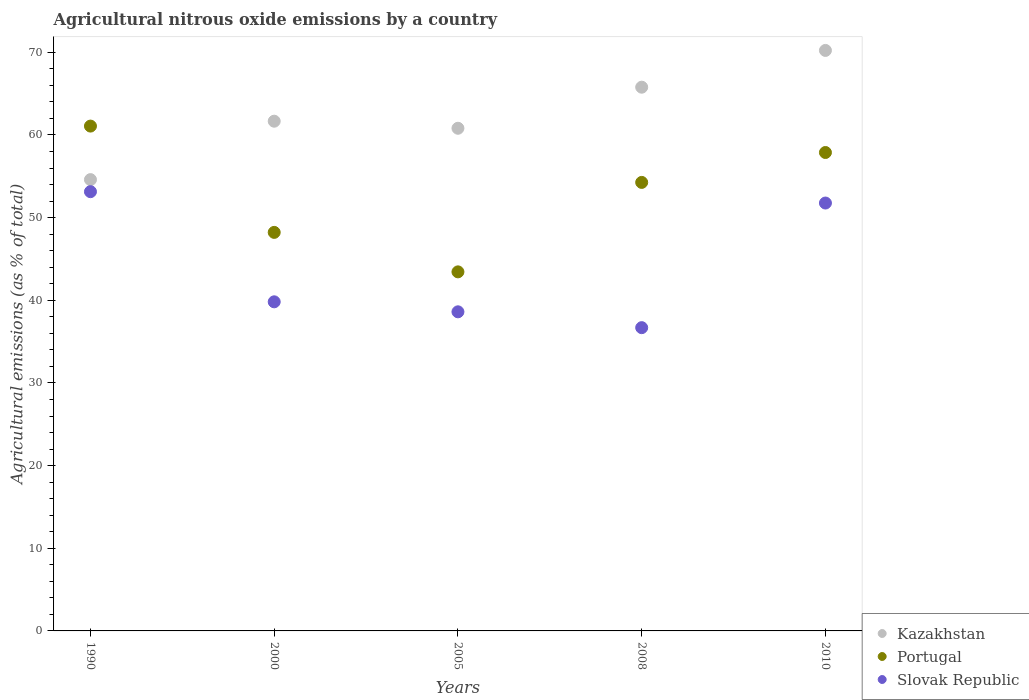How many different coloured dotlines are there?
Ensure brevity in your answer.  3. Is the number of dotlines equal to the number of legend labels?
Your answer should be very brief. Yes. What is the amount of agricultural nitrous oxide emitted in Kazakhstan in 2010?
Give a very brief answer. 70.22. Across all years, what is the maximum amount of agricultural nitrous oxide emitted in Portugal?
Ensure brevity in your answer.  61.07. Across all years, what is the minimum amount of agricultural nitrous oxide emitted in Portugal?
Your answer should be compact. 43.44. In which year was the amount of agricultural nitrous oxide emitted in Portugal minimum?
Offer a very short reply. 2005. What is the total amount of agricultural nitrous oxide emitted in Portugal in the graph?
Ensure brevity in your answer.  264.86. What is the difference between the amount of agricultural nitrous oxide emitted in Kazakhstan in 2005 and that in 2008?
Make the answer very short. -4.97. What is the difference between the amount of agricultural nitrous oxide emitted in Slovak Republic in 2000 and the amount of agricultural nitrous oxide emitted in Portugal in 2010?
Provide a succinct answer. -18.06. What is the average amount of agricultural nitrous oxide emitted in Kazakhstan per year?
Ensure brevity in your answer.  62.61. In the year 2005, what is the difference between the amount of agricultural nitrous oxide emitted in Slovak Republic and amount of agricultural nitrous oxide emitted in Portugal?
Offer a terse response. -4.83. In how many years, is the amount of agricultural nitrous oxide emitted in Portugal greater than 58 %?
Make the answer very short. 1. What is the ratio of the amount of agricultural nitrous oxide emitted in Portugal in 2008 to that in 2010?
Make the answer very short. 0.94. Is the difference between the amount of agricultural nitrous oxide emitted in Slovak Republic in 1990 and 2005 greater than the difference between the amount of agricultural nitrous oxide emitted in Portugal in 1990 and 2005?
Make the answer very short. No. What is the difference between the highest and the second highest amount of agricultural nitrous oxide emitted in Kazakhstan?
Offer a very short reply. 4.45. What is the difference between the highest and the lowest amount of agricultural nitrous oxide emitted in Kazakhstan?
Offer a terse response. 15.63. Is the sum of the amount of agricultural nitrous oxide emitted in Kazakhstan in 2005 and 2010 greater than the maximum amount of agricultural nitrous oxide emitted in Slovak Republic across all years?
Provide a short and direct response. Yes. Does the amount of agricultural nitrous oxide emitted in Kazakhstan monotonically increase over the years?
Offer a terse response. No. Is the amount of agricultural nitrous oxide emitted in Portugal strictly greater than the amount of agricultural nitrous oxide emitted in Slovak Republic over the years?
Offer a terse response. Yes. Is the amount of agricultural nitrous oxide emitted in Portugal strictly less than the amount of agricultural nitrous oxide emitted in Slovak Republic over the years?
Offer a very short reply. No. How many dotlines are there?
Make the answer very short. 3. Does the graph contain any zero values?
Offer a very short reply. No. How many legend labels are there?
Offer a very short reply. 3. What is the title of the graph?
Offer a terse response. Agricultural nitrous oxide emissions by a country. Does "Faeroe Islands" appear as one of the legend labels in the graph?
Ensure brevity in your answer.  No. What is the label or title of the Y-axis?
Offer a very short reply. Agricultural emissions (as % of total). What is the Agricultural emissions (as % of total) of Kazakhstan in 1990?
Make the answer very short. 54.6. What is the Agricultural emissions (as % of total) of Portugal in 1990?
Provide a succinct answer. 61.07. What is the Agricultural emissions (as % of total) in Slovak Republic in 1990?
Your answer should be compact. 53.14. What is the Agricultural emissions (as % of total) of Kazakhstan in 2000?
Provide a succinct answer. 61.66. What is the Agricultural emissions (as % of total) of Portugal in 2000?
Offer a terse response. 48.21. What is the Agricultural emissions (as % of total) of Slovak Republic in 2000?
Make the answer very short. 39.81. What is the Agricultural emissions (as % of total) in Kazakhstan in 2005?
Provide a succinct answer. 60.81. What is the Agricultural emissions (as % of total) of Portugal in 2005?
Make the answer very short. 43.44. What is the Agricultural emissions (as % of total) of Slovak Republic in 2005?
Your answer should be compact. 38.6. What is the Agricultural emissions (as % of total) of Kazakhstan in 2008?
Your response must be concise. 65.78. What is the Agricultural emissions (as % of total) in Portugal in 2008?
Make the answer very short. 54.26. What is the Agricultural emissions (as % of total) in Slovak Republic in 2008?
Offer a very short reply. 36.69. What is the Agricultural emissions (as % of total) of Kazakhstan in 2010?
Give a very brief answer. 70.22. What is the Agricultural emissions (as % of total) in Portugal in 2010?
Offer a terse response. 57.88. What is the Agricultural emissions (as % of total) in Slovak Republic in 2010?
Offer a terse response. 51.76. Across all years, what is the maximum Agricultural emissions (as % of total) of Kazakhstan?
Offer a very short reply. 70.22. Across all years, what is the maximum Agricultural emissions (as % of total) in Portugal?
Provide a succinct answer. 61.07. Across all years, what is the maximum Agricultural emissions (as % of total) in Slovak Republic?
Give a very brief answer. 53.14. Across all years, what is the minimum Agricultural emissions (as % of total) in Kazakhstan?
Offer a terse response. 54.6. Across all years, what is the minimum Agricultural emissions (as % of total) in Portugal?
Provide a short and direct response. 43.44. Across all years, what is the minimum Agricultural emissions (as % of total) in Slovak Republic?
Your response must be concise. 36.69. What is the total Agricultural emissions (as % of total) of Kazakhstan in the graph?
Make the answer very short. 313.07. What is the total Agricultural emissions (as % of total) of Portugal in the graph?
Provide a succinct answer. 264.86. What is the total Agricultural emissions (as % of total) in Slovak Republic in the graph?
Your response must be concise. 220. What is the difference between the Agricultural emissions (as % of total) in Kazakhstan in 1990 and that in 2000?
Make the answer very short. -7.07. What is the difference between the Agricultural emissions (as % of total) of Portugal in 1990 and that in 2000?
Ensure brevity in your answer.  12.86. What is the difference between the Agricultural emissions (as % of total) of Slovak Republic in 1990 and that in 2000?
Provide a succinct answer. 13.32. What is the difference between the Agricultural emissions (as % of total) in Kazakhstan in 1990 and that in 2005?
Offer a terse response. -6.21. What is the difference between the Agricultural emissions (as % of total) of Portugal in 1990 and that in 2005?
Give a very brief answer. 17.63. What is the difference between the Agricultural emissions (as % of total) in Slovak Republic in 1990 and that in 2005?
Your answer should be very brief. 14.53. What is the difference between the Agricultural emissions (as % of total) in Kazakhstan in 1990 and that in 2008?
Your answer should be very brief. -11.18. What is the difference between the Agricultural emissions (as % of total) in Portugal in 1990 and that in 2008?
Your answer should be compact. 6.81. What is the difference between the Agricultural emissions (as % of total) of Slovak Republic in 1990 and that in 2008?
Keep it short and to the point. 16.45. What is the difference between the Agricultural emissions (as % of total) in Kazakhstan in 1990 and that in 2010?
Make the answer very short. -15.63. What is the difference between the Agricultural emissions (as % of total) in Portugal in 1990 and that in 2010?
Your answer should be very brief. 3.2. What is the difference between the Agricultural emissions (as % of total) of Slovak Republic in 1990 and that in 2010?
Provide a short and direct response. 1.37. What is the difference between the Agricultural emissions (as % of total) in Kazakhstan in 2000 and that in 2005?
Give a very brief answer. 0.86. What is the difference between the Agricultural emissions (as % of total) in Portugal in 2000 and that in 2005?
Ensure brevity in your answer.  4.78. What is the difference between the Agricultural emissions (as % of total) in Slovak Republic in 2000 and that in 2005?
Your response must be concise. 1.21. What is the difference between the Agricultural emissions (as % of total) of Kazakhstan in 2000 and that in 2008?
Provide a succinct answer. -4.11. What is the difference between the Agricultural emissions (as % of total) of Portugal in 2000 and that in 2008?
Keep it short and to the point. -6.05. What is the difference between the Agricultural emissions (as % of total) in Slovak Republic in 2000 and that in 2008?
Provide a succinct answer. 3.13. What is the difference between the Agricultural emissions (as % of total) in Kazakhstan in 2000 and that in 2010?
Keep it short and to the point. -8.56. What is the difference between the Agricultural emissions (as % of total) in Portugal in 2000 and that in 2010?
Provide a short and direct response. -9.66. What is the difference between the Agricultural emissions (as % of total) in Slovak Republic in 2000 and that in 2010?
Give a very brief answer. -11.95. What is the difference between the Agricultural emissions (as % of total) of Kazakhstan in 2005 and that in 2008?
Keep it short and to the point. -4.97. What is the difference between the Agricultural emissions (as % of total) of Portugal in 2005 and that in 2008?
Make the answer very short. -10.82. What is the difference between the Agricultural emissions (as % of total) of Slovak Republic in 2005 and that in 2008?
Provide a succinct answer. 1.92. What is the difference between the Agricultural emissions (as % of total) of Kazakhstan in 2005 and that in 2010?
Offer a very short reply. -9.42. What is the difference between the Agricultural emissions (as % of total) of Portugal in 2005 and that in 2010?
Give a very brief answer. -14.44. What is the difference between the Agricultural emissions (as % of total) of Slovak Republic in 2005 and that in 2010?
Your answer should be compact. -13.16. What is the difference between the Agricultural emissions (as % of total) in Kazakhstan in 2008 and that in 2010?
Your answer should be very brief. -4.45. What is the difference between the Agricultural emissions (as % of total) in Portugal in 2008 and that in 2010?
Offer a terse response. -3.62. What is the difference between the Agricultural emissions (as % of total) in Slovak Republic in 2008 and that in 2010?
Offer a terse response. -15.08. What is the difference between the Agricultural emissions (as % of total) in Kazakhstan in 1990 and the Agricultural emissions (as % of total) in Portugal in 2000?
Your answer should be very brief. 6.38. What is the difference between the Agricultural emissions (as % of total) in Kazakhstan in 1990 and the Agricultural emissions (as % of total) in Slovak Republic in 2000?
Keep it short and to the point. 14.78. What is the difference between the Agricultural emissions (as % of total) of Portugal in 1990 and the Agricultural emissions (as % of total) of Slovak Republic in 2000?
Offer a very short reply. 21.26. What is the difference between the Agricultural emissions (as % of total) of Kazakhstan in 1990 and the Agricultural emissions (as % of total) of Portugal in 2005?
Your answer should be compact. 11.16. What is the difference between the Agricultural emissions (as % of total) of Kazakhstan in 1990 and the Agricultural emissions (as % of total) of Slovak Republic in 2005?
Ensure brevity in your answer.  15.99. What is the difference between the Agricultural emissions (as % of total) of Portugal in 1990 and the Agricultural emissions (as % of total) of Slovak Republic in 2005?
Offer a terse response. 22.47. What is the difference between the Agricultural emissions (as % of total) in Kazakhstan in 1990 and the Agricultural emissions (as % of total) in Portugal in 2008?
Provide a succinct answer. 0.34. What is the difference between the Agricultural emissions (as % of total) in Kazakhstan in 1990 and the Agricultural emissions (as % of total) in Slovak Republic in 2008?
Provide a short and direct response. 17.91. What is the difference between the Agricultural emissions (as % of total) in Portugal in 1990 and the Agricultural emissions (as % of total) in Slovak Republic in 2008?
Make the answer very short. 24.38. What is the difference between the Agricultural emissions (as % of total) of Kazakhstan in 1990 and the Agricultural emissions (as % of total) of Portugal in 2010?
Offer a very short reply. -3.28. What is the difference between the Agricultural emissions (as % of total) of Kazakhstan in 1990 and the Agricultural emissions (as % of total) of Slovak Republic in 2010?
Offer a very short reply. 2.83. What is the difference between the Agricultural emissions (as % of total) of Portugal in 1990 and the Agricultural emissions (as % of total) of Slovak Republic in 2010?
Make the answer very short. 9.31. What is the difference between the Agricultural emissions (as % of total) in Kazakhstan in 2000 and the Agricultural emissions (as % of total) in Portugal in 2005?
Offer a terse response. 18.23. What is the difference between the Agricultural emissions (as % of total) of Kazakhstan in 2000 and the Agricultural emissions (as % of total) of Slovak Republic in 2005?
Your answer should be very brief. 23.06. What is the difference between the Agricultural emissions (as % of total) in Portugal in 2000 and the Agricultural emissions (as % of total) in Slovak Republic in 2005?
Your response must be concise. 9.61. What is the difference between the Agricultural emissions (as % of total) of Kazakhstan in 2000 and the Agricultural emissions (as % of total) of Portugal in 2008?
Your answer should be compact. 7.4. What is the difference between the Agricultural emissions (as % of total) in Kazakhstan in 2000 and the Agricultural emissions (as % of total) in Slovak Republic in 2008?
Your answer should be very brief. 24.98. What is the difference between the Agricultural emissions (as % of total) in Portugal in 2000 and the Agricultural emissions (as % of total) in Slovak Republic in 2008?
Your answer should be very brief. 11.53. What is the difference between the Agricultural emissions (as % of total) in Kazakhstan in 2000 and the Agricultural emissions (as % of total) in Portugal in 2010?
Offer a very short reply. 3.79. What is the difference between the Agricultural emissions (as % of total) of Kazakhstan in 2000 and the Agricultural emissions (as % of total) of Slovak Republic in 2010?
Ensure brevity in your answer.  9.9. What is the difference between the Agricultural emissions (as % of total) of Portugal in 2000 and the Agricultural emissions (as % of total) of Slovak Republic in 2010?
Keep it short and to the point. -3.55. What is the difference between the Agricultural emissions (as % of total) of Kazakhstan in 2005 and the Agricultural emissions (as % of total) of Portugal in 2008?
Provide a short and direct response. 6.55. What is the difference between the Agricultural emissions (as % of total) in Kazakhstan in 2005 and the Agricultural emissions (as % of total) in Slovak Republic in 2008?
Your response must be concise. 24.12. What is the difference between the Agricultural emissions (as % of total) in Portugal in 2005 and the Agricultural emissions (as % of total) in Slovak Republic in 2008?
Make the answer very short. 6.75. What is the difference between the Agricultural emissions (as % of total) in Kazakhstan in 2005 and the Agricultural emissions (as % of total) in Portugal in 2010?
Keep it short and to the point. 2.93. What is the difference between the Agricultural emissions (as % of total) of Kazakhstan in 2005 and the Agricultural emissions (as % of total) of Slovak Republic in 2010?
Offer a very short reply. 9.05. What is the difference between the Agricultural emissions (as % of total) of Portugal in 2005 and the Agricultural emissions (as % of total) of Slovak Republic in 2010?
Your answer should be compact. -8.33. What is the difference between the Agricultural emissions (as % of total) of Kazakhstan in 2008 and the Agricultural emissions (as % of total) of Portugal in 2010?
Make the answer very short. 7.9. What is the difference between the Agricultural emissions (as % of total) of Kazakhstan in 2008 and the Agricultural emissions (as % of total) of Slovak Republic in 2010?
Keep it short and to the point. 14.01. What is the difference between the Agricultural emissions (as % of total) in Portugal in 2008 and the Agricultural emissions (as % of total) in Slovak Republic in 2010?
Your answer should be very brief. 2.5. What is the average Agricultural emissions (as % of total) in Kazakhstan per year?
Your answer should be very brief. 62.61. What is the average Agricultural emissions (as % of total) in Portugal per year?
Provide a short and direct response. 52.97. What is the average Agricultural emissions (as % of total) in Slovak Republic per year?
Provide a short and direct response. 44. In the year 1990, what is the difference between the Agricultural emissions (as % of total) in Kazakhstan and Agricultural emissions (as % of total) in Portugal?
Provide a succinct answer. -6.48. In the year 1990, what is the difference between the Agricultural emissions (as % of total) of Kazakhstan and Agricultural emissions (as % of total) of Slovak Republic?
Provide a short and direct response. 1.46. In the year 1990, what is the difference between the Agricultural emissions (as % of total) of Portugal and Agricultural emissions (as % of total) of Slovak Republic?
Offer a very short reply. 7.93. In the year 2000, what is the difference between the Agricultural emissions (as % of total) in Kazakhstan and Agricultural emissions (as % of total) in Portugal?
Your answer should be compact. 13.45. In the year 2000, what is the difference between the Agricultural emissions (as % of total) of Kazakhstan and Agricultural emissions (as % of total) of Slovak Republic?
Provide a succinct answer. 21.85. In the year 2000, what is the difference between the Agricultural emissions (as % of total) of Portugal and Agricultural emissions (as % of total) of Slovak Republic?
Give a very brief answer. 8.4. In the year 2005, what is the difference between the Agricultural emissions (as % of total) in Kazakhstan and Agricultural emissions (as % of total) in Portugal?
Give a very brief answer. 17.37. In the year 2005, what is the difference between the Agricultural emissions (as % of total) of Kazakhstan and Agricultural emissions (as % of total) of Slovak Republic?
Ensure brevity in your answer.  22.2. In the year 2005, what is the difference between the Agricultural emissions (as % of total) in Portugal and Agricultural emissions (as % of total) in Slovak Republic?
Give a very brief answer. 4.83. In the year 2008, what is the difference between the Agricultural emissions (as % of total) of Kazakhstan and Agricultural emissions (as % of total) of Portugal?
Offer a very short reply. 11.52. In the year 2008, what is the difference between the Agricultural emissions (as % of total) of Kazakhstan and Agricultural emissions (as % of total) of Slovak Republic?
Provide a succinct answer. 29.09. In the year 2008, what is the difference between the Agricultural emissions (as % of total) in Portugal and Agricultural emissions (as % of total) in Slovak Republic?
Offer a terse response. 17.57. In the year 2010, what is the difference between the Agricultural emissions (as % of total) in Kazakhstan and Agricultural emissions (as % of total) in Portugal?
Offer a terse response. 12.35. In the year 2010, what is the difference between the Agricultural emissions (as % of total) in Kazakhstan and Agricultural emissions (as % of total) in Slovak Republic?
Offer a very short reply. 18.46. In the year 2010, what is the difference between the Agricultural emissions (as % of total) in Portugal and Agricultural emissions (as % of total) in Slovak Republic?
Your answer should be compact. 6.11. What is the ratio of the Agricultural emissions (as % of total) in Kazakhstan in 1990 to that in 2000?
Provide a short and direct response. 0.89. What is the ratio of the Agricultural emissions (as % of total) of Portugal in 1990 to that in 2000?
Your response must be concise. 1.27. What is the ratio of the Agricultural emissions (as % of total) in Slovak Republic in 1990 to that in 2000?
Give a very brief answer. 1.33. What is the ratio of the Agricultural emissions (as % of total) of Kazakhstan in 1990 to that in 2005?
Ensure brevity in your answer.  0.9. What is the ratio of the Agricultural emissions (as % of total) in Portugal in 1990 to that in 2005?
Provide a succinct answer. 1.41. What is the ratio of the Agricultural emissions (as % of total) of Slovak Republic in 1990 to that in 2005?
Offer a very short reply. 1.38. What is the ratio of the Agricultural emissions (as % of total) of Kazakhstan in 1990 to that in 2008?
Your answer should be compact. 0.83. What is the ratio of the Agricultural emissions (as % of total) of Portugal in 1990 to that in 2008?
Give a very brief answer. 1.13. What is the ratio of the Agricultural emissions (as % of total) of Slovak Republic in 1990 to that in 2008?
Offer a very short reply. 1.45. What is the ratio of the Agricultural emissions (as % of total) in Kazakhstan in 1990 to that in 2010?
Offer a terse response. 0.78. What is the ratio of the Agricultural emissions (as % of total) of Portugal in 1990 to that in 2010?
Offer a very short reply. 1.06. What is the ratio of the Agricultural emissions (as % of total) of Slovak Republic in 1990 to that in 2010?
Keep it short and to the point. 1.03. What is the ratio of the Agricultural emissions (as % of total) in Kazakhstan in 2000 to that in 2005?
Offer a very short reply. 1.01. What is the ratio of the Agricultural emissions (as % of total) in Portugal in 2000 to that in 2005?
Ensure brevity in your answer.  1.11. What is the ratio of the Agricultural emissions (as % of total) in Slovak Republic in 2000 to that in 2005?
Offer a terse response. 1.03. What is the ratio of the Agricultural emissions (as % of total) of Kazakhstan in 2000 to that in 2008?
Give a very brief answer. 0.94. What is the ratio of the Agricultural emissions (as % of total) in Portugal in 2000 to that in 2008?
Offer a terse response. 0.89. What is the ratio of the Agricultural emissions (as % of total) of Slovak Republic in 2000 to that in 2008?
Provide a succinct answer. 1.09. What is the ratio of the Agricultural emissions (as % of total) of Kazakhstan in 2000 to that in 2010?
Provide a succinct answer. 0.88. What is the ratio of the Agricultural emissions (as % of total) in Portugal in 2000 to that in 2010?
Offer a very short reply. 0.83. What is the ratio of the Agricultural emissions (as % of total) of Slovak Republic in 2000 to that in 2010?
Your answer should be compact. 0.77. What is the ratio of the Agricultural emissions (as % of total) in Kazakhstan in 2005 to that in 2008?
Offer a terse response. 0.92. What is the ratio of the Agricultural emissions (as % of total) in Portugal in 2005 to that in 2008?
Ensure brevity in your answer.  0.8. What is the ratio of the Agricultural emissions (as % of total) in Slovak Republic in 2005 to that in 2008?
Provide a succinct answer. 1.05. What is the ratio of the Agricultural emissions (as % of total) of Kazakhstan in 2005 to that in 2010?
Offer a terse response. 0.87. What is the ratio of the Agricultural emissions (as % of total) in Portugal in 2005 to that in 2010?
Keep it short and to the point. 0.75. What is the ratio of the Agricultural emissions (as % of total) in Slovak Republic in 2005 to that in 2010?
Keep it short and to the point. 0.75. What is the ratio of the Agricultural emissions (as % of total) of Kazakhstan in 2008 to that in 2010?
Your answer should be compact. 0.94. What is the ratio of the Agricultural emissions (as % of total) in Portugal in 2008 to that in 2010?
Offer a terse response. 0.94. What is the ratio of the Agricultural emissions (as % of total) in Slovak Republic in 2008 to that in 2010?
Your answer should be compact. 0.71. What is the difference between the highest and the second highest Agricultural emissions (as % of total) of Kazakhstan?
Give a very brief answer. 4.45. What is the difference between the highest and the second highest Agricultural emissions (as % of total) in Portugal?
Provide a succinct answer. 3.2. What is the difference between the highest and the second highest Agricultural emissions (as % of total) in Slovak Republic?
Give a very brief answer. 1.37. What is the difference between the highest and the lowest Agricultural emissions (as % of total) in Kazakhstan?
Your response must be concise. 15.63. What is the difference between the highest and the lowest Agricultural emissions (as % of total) in Portugal?
Your answer should be compact. 17.63. What is the difference between the highest and the lowest Agricultural emissions (as % of total) of Slovak Republic?
Provide a succinct answer. 16.45. 